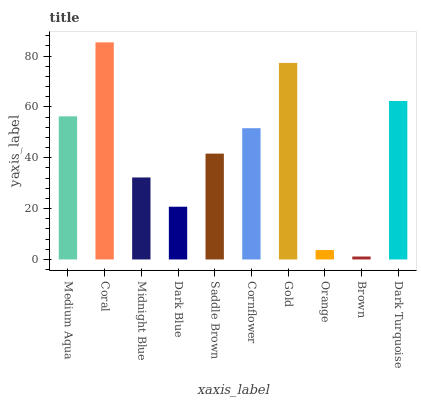Is Brown the minimum?
Answer yes or no. Yes. Is Coral the maximum?
Answer yes or no. Yes. Is Midnight Blue the minimum?
Answer yes or no. No. Is Midnight Blue the maximum?
Answer yes or no. No. Is Coral greater than Midnight Blue?
Answer yes or no. Yes. Is Midnight Blue less than Coral?
Answer yes or no. Yes. Is Midnight Blue greater than Coral?
Answer yes or no. No. Is Coral less than Midnight Blue?
Answer yes or no. No. Is Cornflower the high median?
Answer yes or no. Yes. Is Saddle Brown the low median?
Answer yes or no. Yes. Is Orange the high median?
Answer yes or no. No. Is Orange the low median?
Answer yes or no. No. 